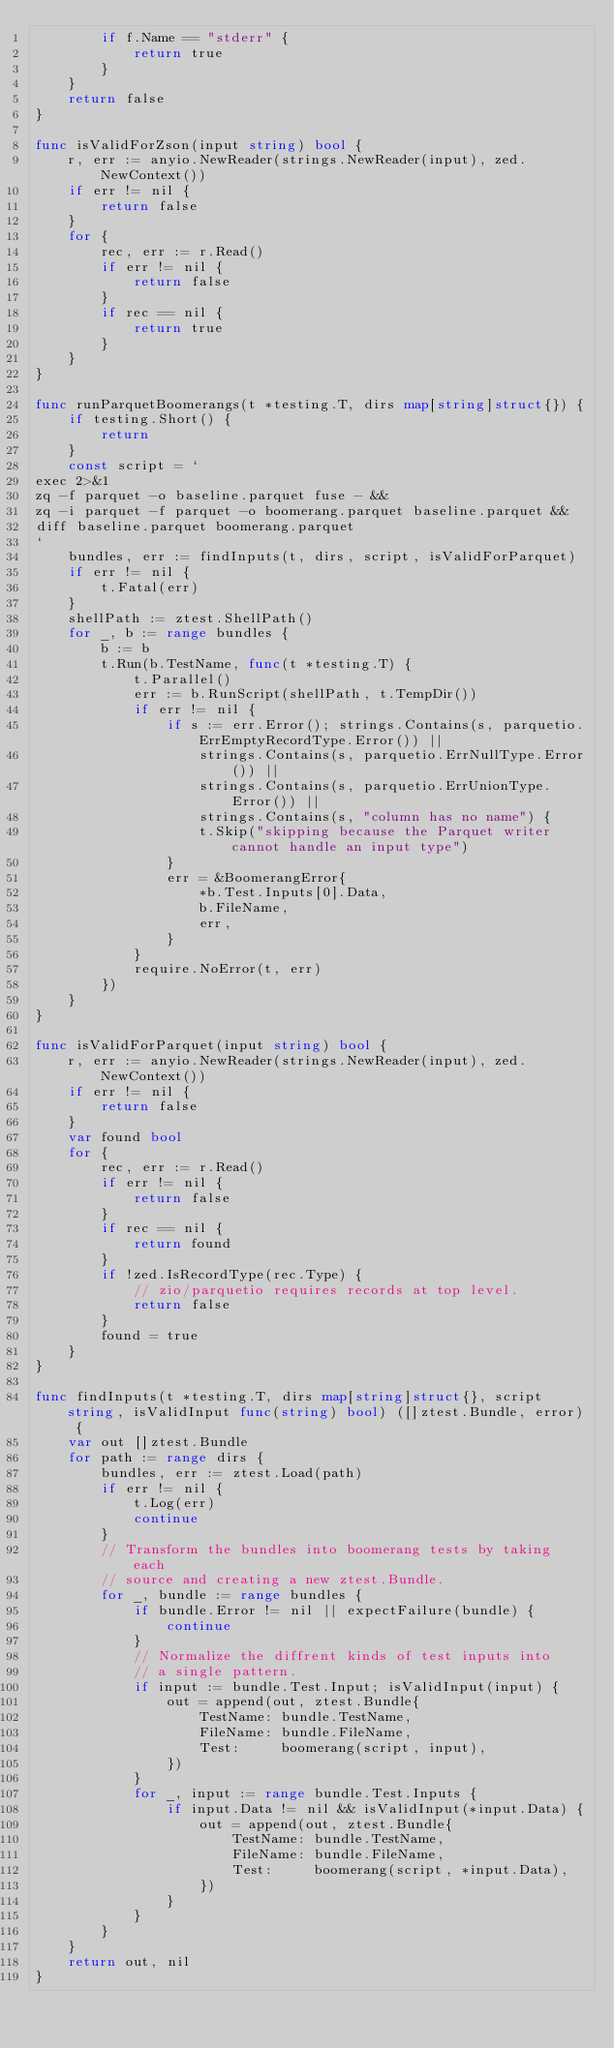Convert code to text. <code><loc_0><loc_0><loc_500><loc_500><_Go_>		if f.Name == "stderr" {
			return true
		}
	}
	return false
}

func isValidForZson(input string) bool {
	r, err := anyio.NewReader(strings.NewReader(input), zed.NewContext())
	if err != nil {
		return false
	}
	for {
		rec, err := r.Read()
		if err != nil {
			return false
		}
		if rec == nil {
			return true
		}
	}
}

func runParquetBoomerangs(t *testing.T, dirs map[string]struct{}) {
	if testing.Short() {
		return
	}
	const script = `
exec 2>&1
zq -f parquet -o baseline.parquet fuse - &&
zq -i parquet -f parquet -o boomerang.parquet baseline.parquet &&
diff baseline.parquet boomerang.parquet
`
	bundles, err := findInputs(t, dirs, script, isValidForParquet)
	if err != nil {
		t.Fatal(err)
	}
	shellPath := ztest.ShellPath()
	for _, b := range bundles {
		b := b
		t.Run(b.TestName, func(t *testing.T) {
			t.Parallel()
			err := b.RunScript(shellPath, t.TempDir())
			if err != nil {
				if s := err.Error(); strings.Contains(s, parquetio.ErrEmptyRecordType.Error()) ||
					strings.Contains(s, parquetio.ErrNullType.Error()) ||
					strings.Contains(s, parquetio.ErrUnionType.Error()) ||
					strings.Contains(s, "column has no name") {
					t.Skip("skipping because the Parquet writer cannot handle an input type")
				}
				err = &BoomerangError{
					*b.Test.Inputs[0].Data,
					b.FileName,
					err,
				}
			}
			require.NoError(t, err)
		})
	}
}

func isValidForParquet(input string) bool {
	r, err := anyio.NewReader(strings.NewReader(input), zed.NewContext())
	if err != nil {
		return false
	}
	var found bool
	for {
		rec, err := r.Read()
		if err != nil {
			return false
		}
		if rec == nil {
			return found
		}
		if !zed.IsRecordType(rec.Type) {
			// zio/parquetio requires records at top level.
			return false
		}
		found = true
	}
}

func findInputs(t *testing.T, dirs map[string]struct{}, script string, isValidInput func(string) bool) ([]ztest.Bundle, error) {
	var out []ztest.Bundle
	for path := range dirs {
		bundles, err := ztest.Load(path)
		if err != nil {
			t.Log(err)
			continue
		}
		// Transform the bundles into boomerang tests by taking each
		// source and creating a new ztest.Bundle.
		for _, bundle := range bundles {
			if bundle.Error != nil || expectFailure(bundle) {
				continue
			}
			// Normalize the diffrent kinds of test inputs into
			// a single pattern.
			if input := bundle.Test.Input; isValidInput(input) {
				out = append(out, ztest.Bundle{
					TestName: bundle.TestName,
					FileName: bundle.FileName,
					Test:     boomerang(script, input),
				})
			}
			for _, input := range bundle.Test.Inputs {
				if input.Data != nil && isValidInput(*input.Data) {
					out = append(out, ztest.Bundle{
						TestName: bundle.TestName,
						FileName: bundle.FileName,
						Test:     boomerang(script, *input.Data),
					})
				}
			}
		}
	}
	return out, nil
}
</code> 